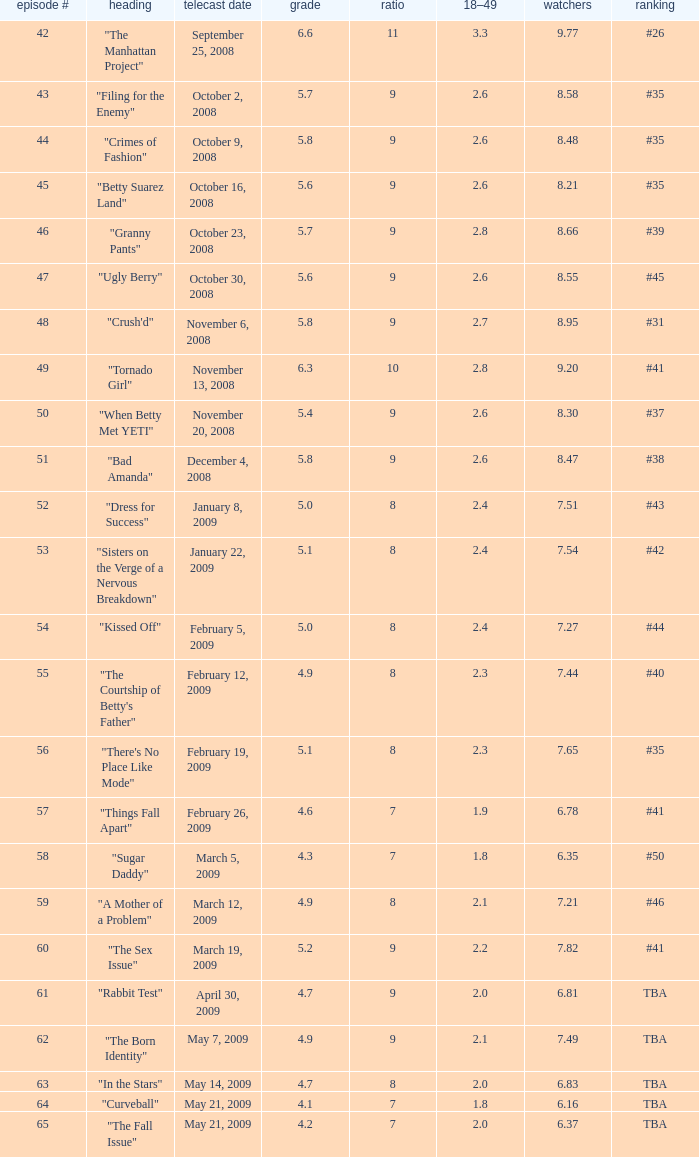What is the least amount of viewers for an episode named "curveball" with an episode number exceeding 58 and a rating of less than 4.1? None. Could you help me parse every detail presented in this table? {'header': ['episode #', 'heading', 'telecast date', 'grade', 'ratio', '18–49', 'watchers', 'ranking'], 'rows': [['42', '"The Manhattan Project"', 'September 25, 2008', '6.6', '11', '3.3', '9.77', '#26'], ['43', '"Filing for the Enemy"', 'October 2, 2008', '5.7', '9', '2.6', '8.58', '#35'], ['44', '"Crimes of Fashion"', 'October 9, 2008', '5.8', '9', '2.6', '8.48', '#35'], ['45', '"Betty Suarez Land"', 'October 16, 2008', '5.6', '9', '2.6', '8.21', '#35'], ['46', '"Granny Pants"', 'October 23, 2008', '5.7', '9', '2.8', '8.66', '#39'], ['47', '"Ugly Berry"', 'October 30, 2008', '5.6', '9', '2.6', '8.55', '#45'], ['48', '"Crush\'d"', 'November 6, 2008', '5.8', '9', '2.7', '8.95', '#31'], ['49', '"Tornado Girl"', 'November 13, 2008', '6.3', '10', '2.8', '9.20', '#41'], ['50', '"When Betty Met YETI"', 'November 20, 2008', '5.4', '9', '2.6', '8.30', '#37'], ['51', '"Bad Amanda"', 'December 4, 2008', '5.8', '9', '2.6', '8.47', '#38'], ['52', '"Dress for Success"', 'January 8, 2009', '5.0', '8', '2.4', '7.51', '#43'], ['53', '"Sisters on the Verge of a Nervous Breakdown"', 'January 22, 2009', '5.1', '8', '2.4', '7.54', '#42'], ['54', '"Kissed Off"', 'February 5, 2009', '5.0', '8', '2.4', '7.27', '#44'], ['55', '"The Courtship of Betty\'s Father"', 'February 12, 2009', '4.9', '8', '2.3', '7.44', '#40'], ['56', '"There\'s No Place Like Mode"', 'February 19, 2009', '5.1', '8', '2.3', '7.65', '#35'], ['57', '"Things Fall Apart"', 'February 26, 2009', '4.6', '7', '1.9', '6.78', '#41'], ['58', '"Sugar Daddy"', 'March 5, 2009', '4.3', '7', '1.8', '6.35', '#50'], ['59', '"A Mother of a Problem"', 'March 12, 2009', '4.9', '8', '2.1', '7.21', '#46'], ['60', '"The Sex Issue"', 'March 19, 2009', '5.2', '9', '2.2', '7.82', '#41'], ['61', '"Rabbit Test"', 'April 30, 2009', '4.7', '9', '2.0', '6.81', 'TBA'], ['62', '"The Born Identity"', 'May 7, 2009', '4.9', '9', '2.1', '7.49', 'TBA'], ['63', '"In the Stars"', 'May 14, 2009', '4.7', '8', '2.0', '6.83', 'TBA'], ['64', '"Curveball"', 'May 21, 2009', '4.1', '7', '1.8', '6.16', 'TBA'], ['65', '"The Fall Issue"', 'May 21, 2009', '4.2', '7', '2.0', '6.37', 'TBA']]} 